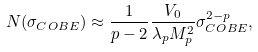Convert formula to latex. <formula><loc_0><loc_0><loc_500><loc_500>N ( \sigma _ { C O B E } ) \approx \frac { 1 } { p - 2 } \frac { V _ { 0 } } { \lambda _ { p } M _ { p } ^ { 2 } } \sigma _ { C O B E } ^ { 2 - p } ,</formula> 